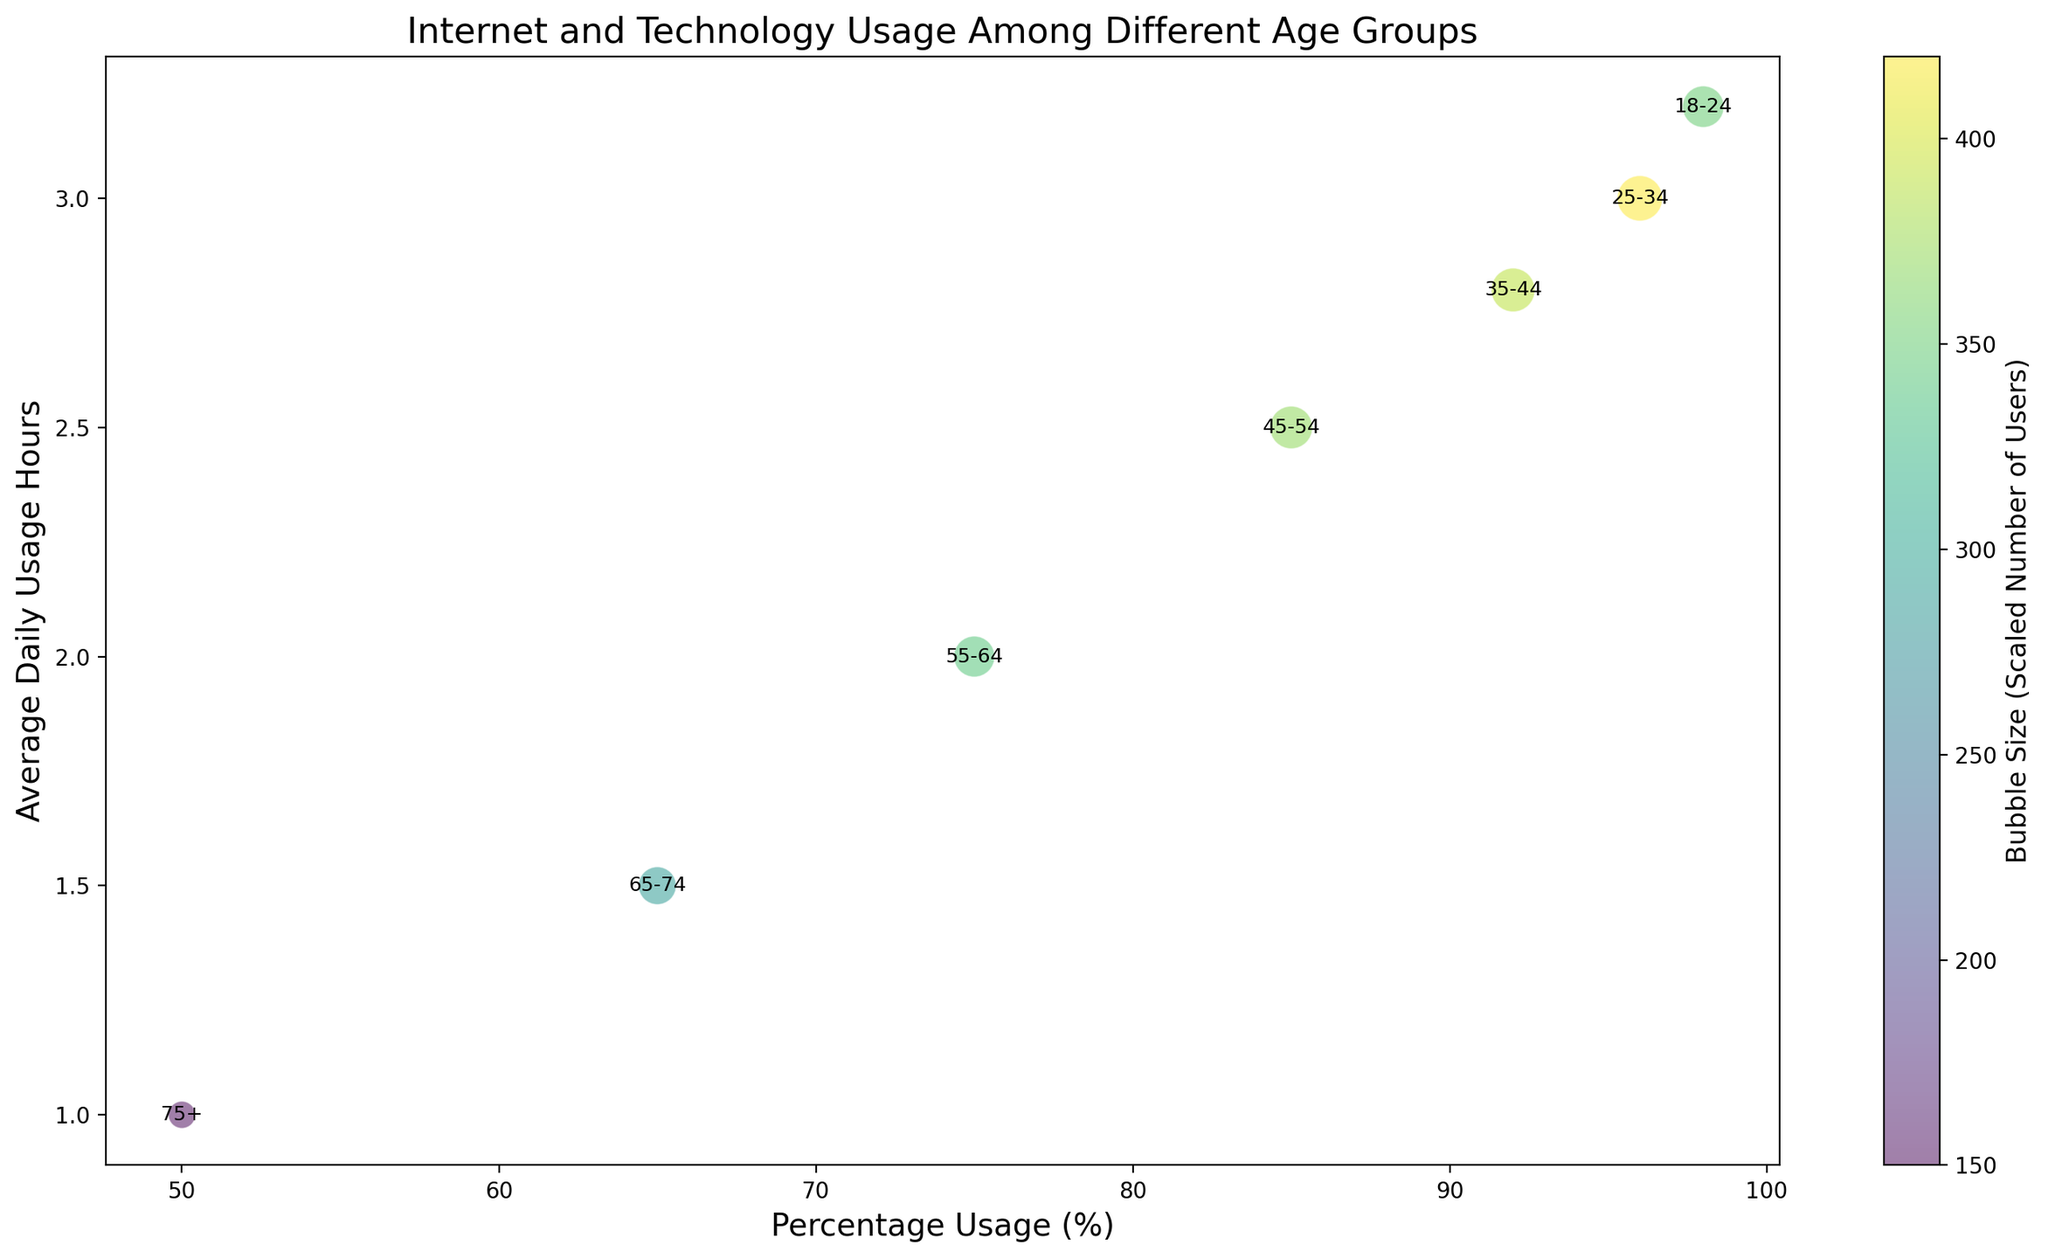What's the age group with the lowest percentage usage? Identify the bubble that is the furthest to the left. The age group labeled "75+" has the lowest percentage usage because its bubble is positioned the farthest left on the x-axis.
Answer: 75+ Which age group has the highest average daily usage hours? Look for the bubble that is positioned the highest on the y-axis. The age group "18-24" has the highest average daily usage hours because its bubble is at the top.
Answer: 18-24 How does the percentage usage of the 35-44 age group compare to the 65-74 age group? Compare the position of the 35-44 bubble on the x-axis (left to right) to the 65-74 bubble. The 35-44 age group has a higher percentage usage than the 65-74 age group because it is further to the right on the x-axis.
Answer: Higher What is the difference in average daily hours between the 45-54 and 55-64 age groups? Identify the position of the 45-54 bubble and the 55-64 bubble on the y-axis, and subtract the value of the latter from the former. The difference in average daily hours is 2.5 - 2.0 = 0.5 hours.
Answer: 0.5 hours Which age group has the largest bubble size, indicating the highest number of users? Find the largest bubble on the chart. The age group "25-34" has the largest bubble, indicating the highest number of users.
Answer: 25-34 How does the bubble color for the 75+ age group compare to the color of other groups? Observe the color (which represents the scaled number of users) of the 75+ bubble and compare it to other bubbles. The 75+ bubble is the smallest and likely the lightest in color, indicating the fewest users.
Answer: Lightest in color What is the average of the percentage usage between the 18-24 and 25-34 age groups? Add the percentage usage for the 18-24 age group (98%) and the 25-34 age group (96%), then divide by 2. The average is (98 + 96) / 2 = 97%.
Answer: 97% Which age group shows a sharp decrease in both percentage usage and average daily hours compared to the previous age group? Compare the bubbles on both axes to find a significant drop from one age group to the next. The sharpest decrease is observed between the 55-64 and the 65-74 age groups.
Answer: 65-74 